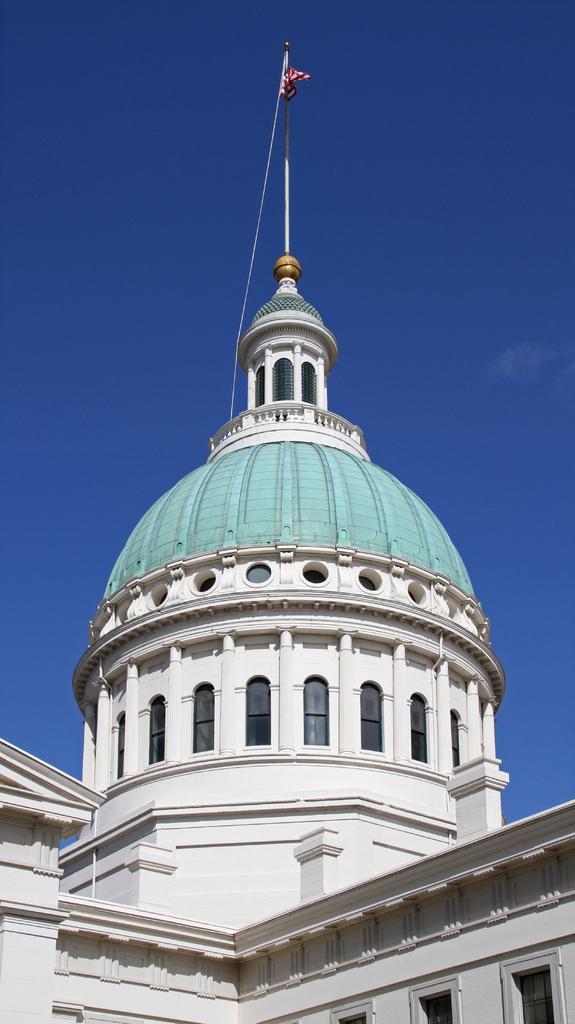Please provide a concise description of this image. In this image we can see a white color monument and we can see the flag here. In the background, we can see the blue color sky. 